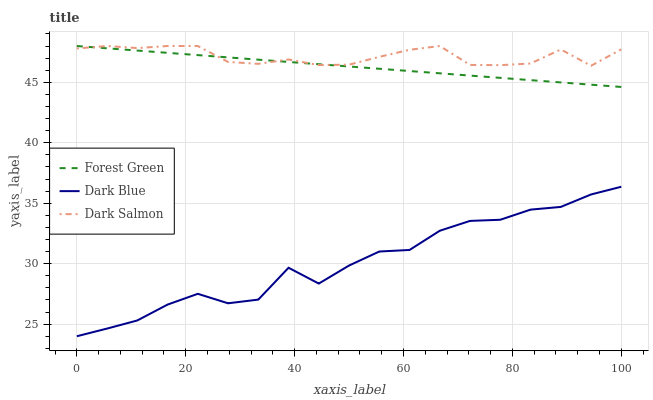Does Dark Blue have the minimum area under the curve?
Answer yes or no. Yes. Does Dark Salmon have the maximum area under the curve?
Answer yes or no. Yes. Does Forest Green have the minimum area under the curve?
Answer yes or no. No. Does Forest Green have the maximum area under the curve?
Answer yes or no. No. Is Forest Green the smoothest?
Answer yes or no. Yes. Is Dark Blue the roughest?
Answer yes or no. Yes. Is Dark Salmon the smoothest?
Answer yes or no. No. Is Dark Salmon the roughest?
Answer yes or no. No. Does Dark Blue have the lowest value?
Answer yes or no. Yes. Does Forest Green have the lowest value?
Answer yes or no. No. Does Dark Salmon have the highest value?
Answer yes or no. Yes. Is Dark Blue less than Forest Green?
Answer yes or no. Yes. Is Dark Salmon greater than Dark Blue?
Answer yes or no. Yes. Does Dark Salmon intersect Forest Green?
Answer yes or no. Yes. Is Dark Salmon less than Forest Green?
Answer yes or no. No. Is Dark Salmon greater than Forest Green?
Answer yes or no. No. Does Dark Blue intersect Forest Green?
Answer yes or no. No. 